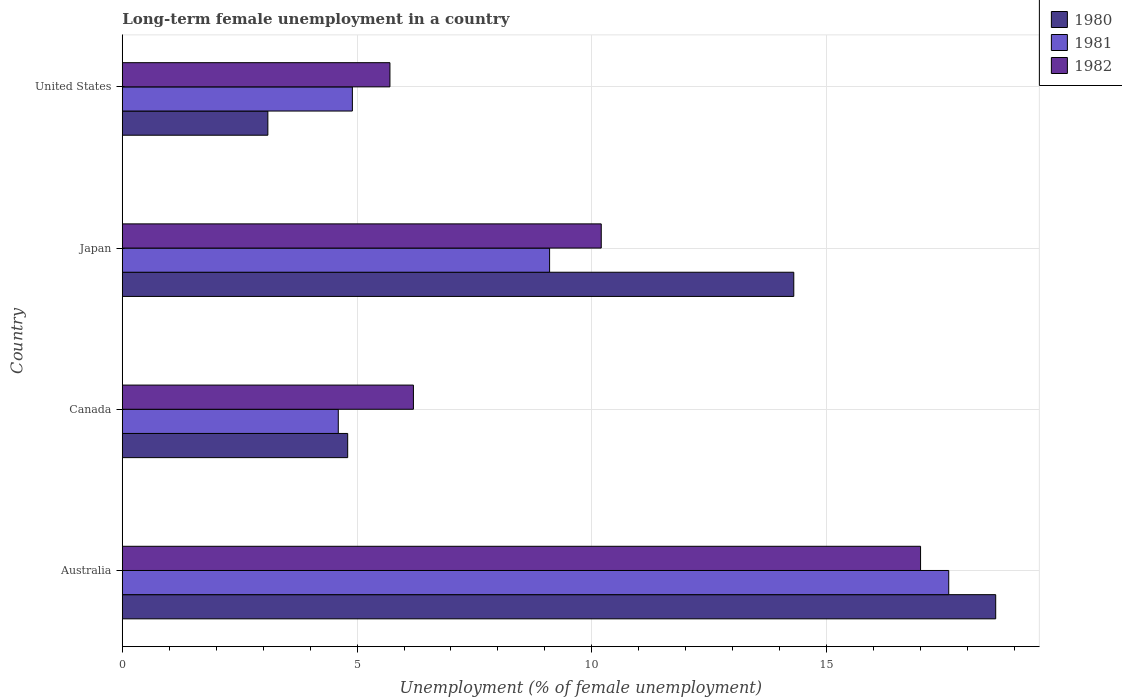How many different coloured bars are there?
Provide a succinct answer. 3. How many groups of bars are there?
Offer a terse response. 4. Are the number of bars on each tick of the Y-axis equal?
Give a very brief answer. Yes. How many bars are there on the 3rd tick from the bottom?
Keep it short and to the point. 3. What is the percentage of long-term unemployed female population in 1981 in Australia?
Make the answer very short. 17.6. Across all countries, what is the maximum percentage of long-term unemployed female population in 1980?
Ensure brevity in your answer.  18.6. Across all countries, what is the minimum percentage of long-term unemployed female population in 1982?
Your answer should be very brief. 5.7. In which country was the percentage of long-term unemployed female population in 1980 maximum?
Offer a very short reply. Australia. What is the total percentage of long-term unemployed female population in 1981 in the graph?
Give a very brief answer. 36.2. What is the difference between the percentage of long-term unemployed female population in 1981 in Canada and that in United States?
Ensure brevity in your answer.  -0.3. What is the difference between the percentage of long-term unemployed female population in 1981 in Japan and the percentage of long-term unemployed female population in 1982 in Canada?
Keep it short and to the point. 2.9. What is the average percentage of long-term unemployed female population in 1981 per country?
Your response must be concise. 9.05. What is the difference between the percentage of long-term unemployed female population in 1982 and percentage of long-term unemployed female population in 1980 in Australia?
Provide a short and direct response. -1.6. What is the ratio of the percentage of long-term unemployed female population in 1980 in Australia to that in Japan?
Make the answer very short. 1.3. What is the difference between the highest and the second highest percentage of long-term unemployed female population in 1980?
Offer a terse response. 4.3. What is the difference between the highest and the lowest percentage of long-term unemployed female population in 1980?
Make the answer very short. 15.5. Is the sum of the percentage of long-term unemployed female population in 1980 in Australia and United States greater than the maximum percentage of long-term unemployed female population in 1981 across all countries?
Provide a succinct answer. Yes. What does the 1st bar from the top in Japan represents?
Give a very brief answer. 1982. What does the 1st bar from the bottom in United States represents?
Keep it short and to the point. 1980. Are the values on the major ticks of X-axis written in scientific E-notation?
Make the answer very short. No. How many legend labels are there?
Your answer should be compact. 3. How are the legend labels stacked?
Keep it short and to the point. Vertical. What is the title of the graph?
Provide a succinct answer. Long-term female unemployment in a country. Does "1960" appear as one of the legend labels in the graph?
Ensure brevity in your answer.  No. What is the label or title of the X-axis?
Provide a succinct answer. Unemployment (% of female unemployment). What is the label or title of the Y-axis?
Your answer should be very brief. Country. What is the Unemployment (% of female unemployment) in 1980 in Australia?
Give a very brief answer. 18.6. What is the Unemployment (% of female unemployment) of 1981 in Australia?
Keep it short and to the point. 17.6. What is the Unemployment (% of female unemployment) in 1980 in Canada?
Your answer should be compact. 4.8. What is the Unemployment (% of female unemployment) in 1981 in Canada?
Your answer should be very brief. 4.6. What is the Unemployment (% of female unemployment) in 1982 in Canada?
Ensure brevity in your answer.  6.2. What is the Unemployment (% of female unemployment) of 1980 in Japan?
Give a very brief answer. 14.3. What is the Unemployment (% of female unemployment) of 1981 in Japan?
Give a very brief answer. 9.1. What is the Unemployment (% of female unemployment) of 1982 in Japan?
Your answer should be very brief. 10.2. What is the Unemployment (% of female unemployment) of 1980 in United States?
Give a very brief answer. 3.1. What is the Unemployment (% of female unemployment) of 1981 in United States?
Offer a very short reply. 4.9. What is the Unemployment (% of female unemployment) in 1982 in United States?
Provide a short and direct response. 5.7. Across all countries, what is the maximum Unemployment (% of female unemployment) of 1980?
Provide a short and direct response. 18.6. Across all countries, what is the maximum Unemployment (% of female unemployment) in 1981?
Your answer should be very brief. 17.6. Across all countries, what is the minimum Unemployment (% of female unemployment) in 1980?
Ensure brevity in your answer.  3.1. Across all countries, what is the minimum Unemployment (% of female unemployment) of 1981?
Your response must be concise. 4.6. Across all countries, what is the minimum Unemployment (% of female unemployment) in 1982?
Keep it short and to the point. 5.7. What is the total Unemployment (% of female unemployment) of 1980 in the graph?
Provide a short and direct response. 40.8. What is the total Unemployment (% of female unemployment) of 1981 in the graph?
Keep it short and to the point. 36.2. What is the total Unemployment (% of female unemployment) of 1982 in the graph?
Your response must be concise. 39.1. What is the difference between the Unemployment (% of female unemployment) in 1980 in Australia and that in Canada?
Provide a succinct answer. 13.8. What is the difference between the Unemployment (% of female unemployment) of 1980 in Australia and that in Japan?
Your answer should be very brief. 4.3. What is the difference between the Unemployment (% of female unemployment) of 1982 in Australia and that in Japan?
Your answer should be compact. 6.8. What is the difference between the Unemployment (% of female unemployment) in 1980 in Australia and that in United States?
Offer a terse response. 15.5. What is the difference between the Unemployment (% of female unemployment) in 1981 in Australia and that in United States?
Your answer should be compact. 12.7. What is the difference between the Unemployment (% of female unemployment) of 1981 in Canada and that in United States?
Your answer should be very brief. -0.3. What is the difference between the Unemployment (% of female unemployment) in 1982 in Canada and that in United States?
Keep it short and to the point. 0.5. What is the difference between the Unemployment (% of female unemployment) in 1980 in Japan and that in United States?
Offer a very short reply. 11.2. What is the difference between the Unemployment (% of female unemployment) of 1980 in Australia and the Unemployment (% of female unemployment) of 1981 in Canada?
Keep it short and to the point. 14. What is the difference between the Unemployment (% of female unemployment) of 1981 in Australia and the Unemployment (% of female unemployment) of 1982 in Canada?
Ensure brevity in your answer.  11.4. What is the difference between the Unemployment (% of female unemployment) of 1981 in Australia and the Unemployment (% of female unemployment) of 1982 in United States?
Keep it short and to the point. 11.9. What is the difference between the Unemployment (% of female unemployment) of 1981 in Canada and the Unemployment (% of female unemployment) of 1982 in Japan?
Make the answer very short. -5.6. What is the difference between the Unemployment (% of female unemployment) in 1980 in Canada and the Unemployment (% of female unemployment) in 1982 in United States?
Your answer should be compact. -0.9. What is the difference between the Unemployment (% of female unemployment) of 1981 in Canada and the Unemployment (% of female unemployment) of 1982 in United States?
Ensure brevity in your answer.  -1.1. What is the difference between the Unemployment (% of female unemployment) in 1980 in Japan and the Unemployment (% of female unemployment) in 1981 in United States?
Your answer should be very brief. 9.4. What is the difference between the Unemployment (% of female unemployment) in 1981 in Japan and the Unemployment (% of female unemployment) in 1982 in United States?
Your answer should be very brief. 3.4. What is the average Unemployment (% of female unemployment) of 1981 per country?
Your answer should be compact. 9.05. What is the average Unemployment (% of female unemployment) of 1982 per country?
Your answer should be very brief. 9.78. What is the difference between the Unemployment (% of female unemployment) in 1980 and Unemployment (% of female unemployment) in 1982 in Australia?
Offer a terse response. 1.6. What is the difference between the Unemployment (% of female unemployment) of 1981 and Unemployment (% of female unemployment) of 1982 in Canada?
Offer a very short reply. -1.6. What is the difference between the Unemployment (% of female unemployment) of 1981 and Unemployment (% of female unemployment) of 1982 in Japan?
Your response must be concise. -1.1. What is the difference between the Unemployment (% of female unemployment) in 1980 and Unemployment (% of female unemployment) in 1982 in United States?
Your answer should be compact. -2.6. What is the ratio of the Unemployment (% of female unemployment) in 1980 in Australia to that in Canada?
Your response must be concise. 3.88. What is the ratio of the Unemployment (% of female unemployment) in 1981 in Australia to that in Canada?
Provide a succinct answer. 3.83. What is the ratio of the Unemployment (% of female unemployment) of 1982 in Australia to that in Canada?
Your response must be concise. 2.74. What is the ratio of the Unemployment (% of female unemployment) in 1980 in Australia to that in Japan?
Offer a terse response. 1.3. What is the ratio of the Unemployment (% of female unemployment) in 1981 in Australia to that in Japan?
Your answer should be very brief. 1.93. What is the ratio of the Unemployment (% of female unemployment) of 1980 in Australia to that in United States?
Your response must be concise. 6. What is the ratio of the Unemployment (% of female unemployment) of 1981 in Australia to that in United States?
Your answer should be very brief. 3.59. What is the ratio of the Unemployment (% of female unemployment) of 1982 in Australia to that in United States?
Ensure brevity in your answer.  2.98. What is the ratio of the Unemployment (% of female unemployment) in 1980 in Canada to that in Japan?
Offer a terse response. 0.34. What is the ratio of the Unemployment (% of female unemployment) of 1981 in Canada to that in Japan?
Offer a terse response. 0.51. What is the ratio of the Unemployment (% of female unemployment) in 1982 in Canada to that in Japan?
Make the answer very short. 0.61. What is the ratio of the Unemployment (% of female unemployment) of 1980 in Canada to that in United States?
Offer a very short reply. 1.55. What is the ratio of the Unemployment (% of female unemployment) in 1981 in Canada to that in United States?
Ensure brevity in your answer.  0.94. What is the ratio of the Unemployment (% of female unemployment) in 1982 in Canada to that in United States?
Your response must be concise. 1.09. What is the ratio of the Unemployment (% of female unemployment) of 1980 in Japan to that in United States?
Offer a terse response. 4.61. What is the ratio of the Unemployment (% of female unemployment) in 1981 in Japan to that in United States?
Provide a succinct answer. 1.86. What is the ratio of the Unemployment (% of female unemployment) of 1982 in Japan to that in United States?
Your response must be concise. 1.79. What is the difference between the highest and the second highest Unemployment (% of female unemployment) of 1981?
Your response must be concise. 8.5. What is the difference between the highest and the second highest Unemployment (% of female unemployment) of 1982?
Make the answer very short. 6.8. What is the difference between the highest and the lowest Unemployment (% of female unemployment) of 1982?
Ensure brevity in your answer.  11.3. 